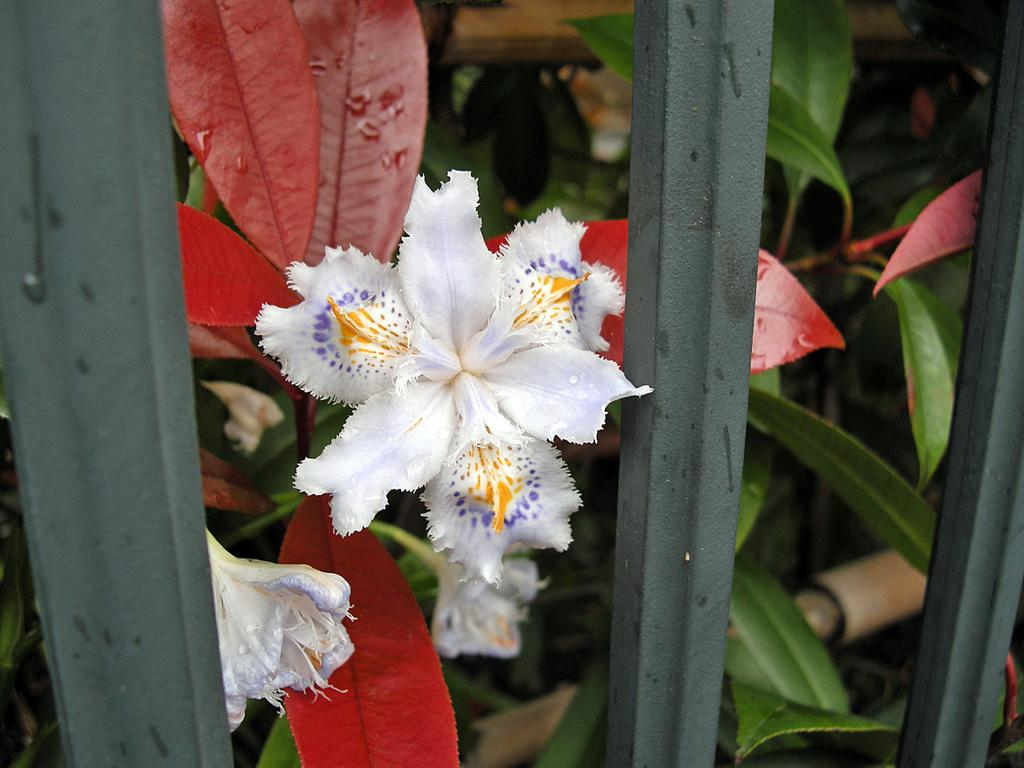What type of vegetation can be seen in the image? There are flowers and leaves in the image. What else can be seen in the image besides vegetation? There are plants and iron poles in the foreground of the image. What expert advice can be given about the point of the image? There is no expert advice needed, as the image is simply a depiction of flowers, leaves, plants, and iron poles. The purpose or point of the image is not relevant to the content. 